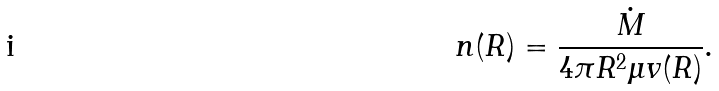Convert formula to latex. <formula><loc_0><loc_0><loc_500><loc_500>n ( R ) = \frac { \dot { M } } { 4 \pi R ^ { 2 } \mu v ( R ) } .</formula> 